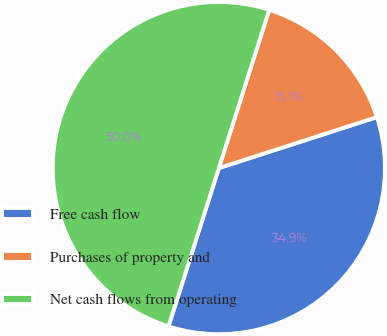Convert chart. <chart><loc_0><loc_0><loc_500><loc_500><pie_chart><fcel>Free cash flow<fcel>Purchases of property and<fcel>Net cash flows from operating<nl><fcel>34.87%<fcel>15.13%<fcel>50.0%<nl></chart> 